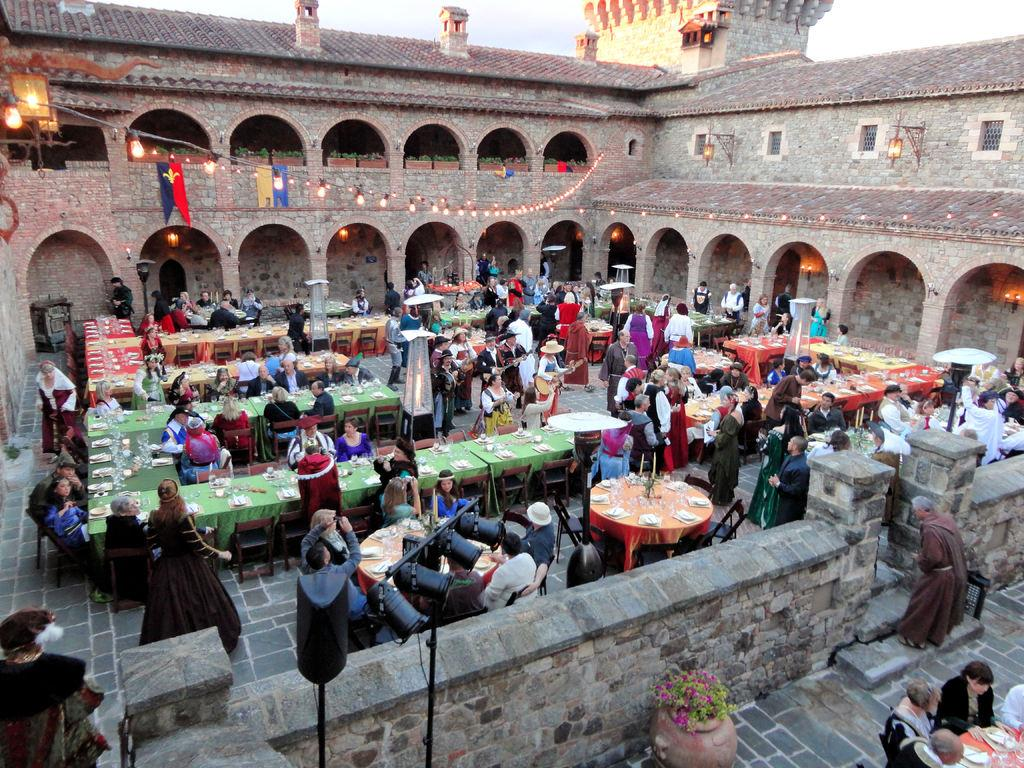What type of location is depicted in the image? The image is taken in a festive area. What type of structure can be seen in the background? The image appears to show an old castle. What is in the middle of the image? There are dining tables in the middle of the image. What furniture is present around the dining tables? Chairs are present in the image. Are there any people in the image? Yes, there are people in the image. How many cows are present in the image? There are no cows visible in the image. What organization is responsible for the festive event in the image? The image does not provide information about the organization responsible for the festive event. 